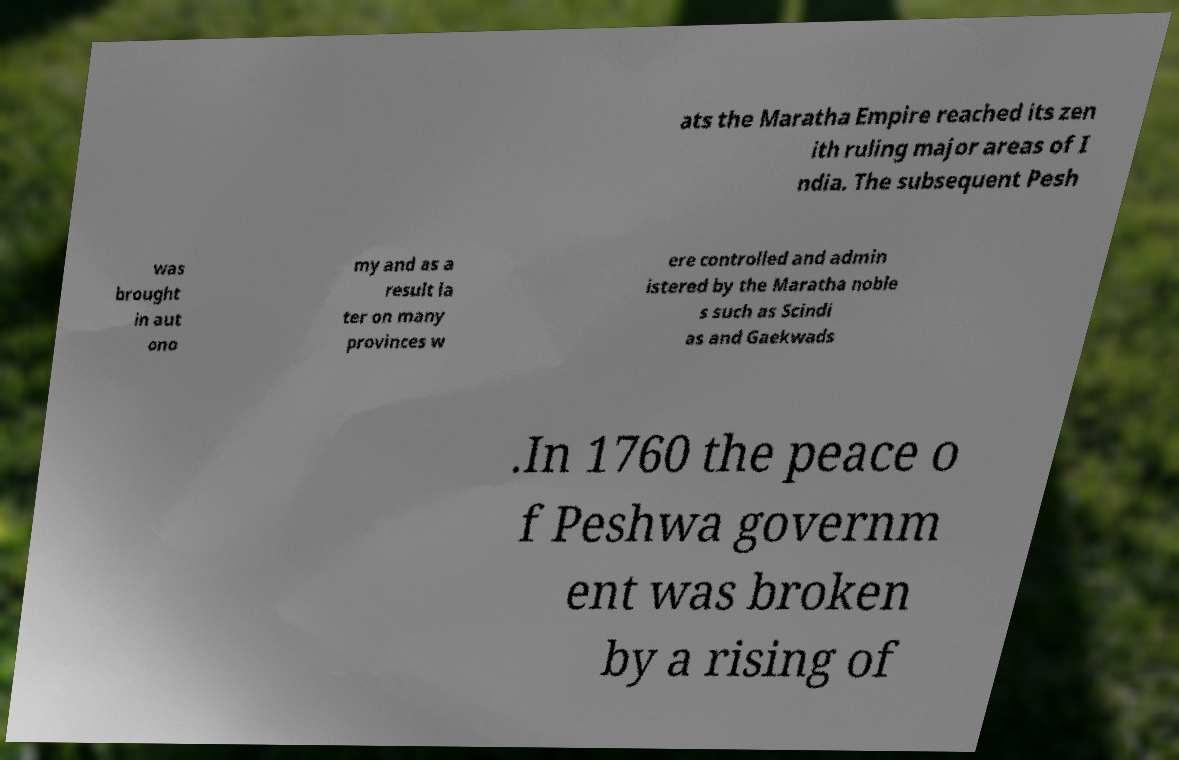Please identify and transcribe the text found in this image. ats the Maratha Empire reached its zen ith ruling major areas of I ndia. The subsequent Pesh was brought in aut ono my and as a result la ter on many provinces w ere controlled and admin istered by the Maratha noble s such as Scindi as and Gaekwads .In 1760 the peace o f Peshwa governm ent was broken by a rising of 